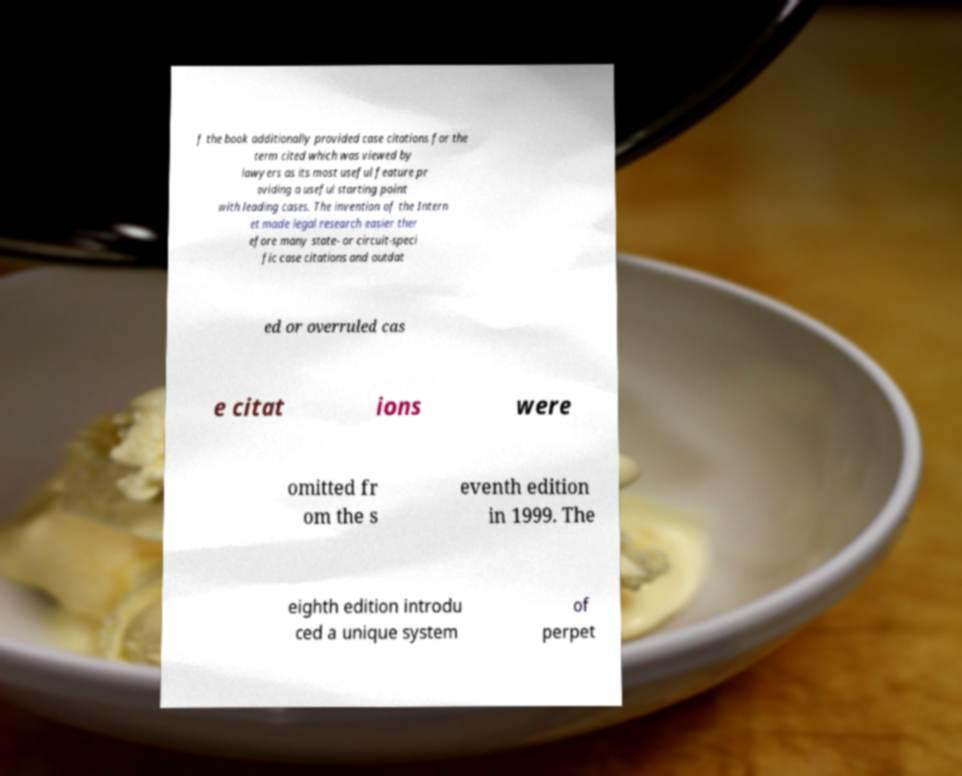Please identify and transcribe the text found in this image. f the book additionally provided case citations for the term cited which was viewed by lawyers as its most useful feature pr oviding a useful starting point with leading cases. The invention of the Intern et made legal research easier ther efore many state- or circuit-speci fic case citations and outdat ed or overruled cas e citat ions were omitted fr om the s eventh edition in 1999. The eighth edition introdu ced a unique system of perpet 